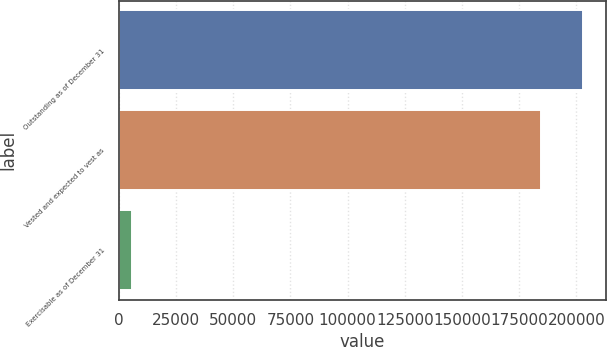Convert chart to OTSL. <chart><loc_0><loc_0><loc_500><loc_500><bar_chart><fcel>Outstanding as of December 31<fcel>Vested and expected to vest as<fcel>Exercisable as of December 31<nl><fcel>202932<fcel>184636<fcel>5883<nl></chart> 